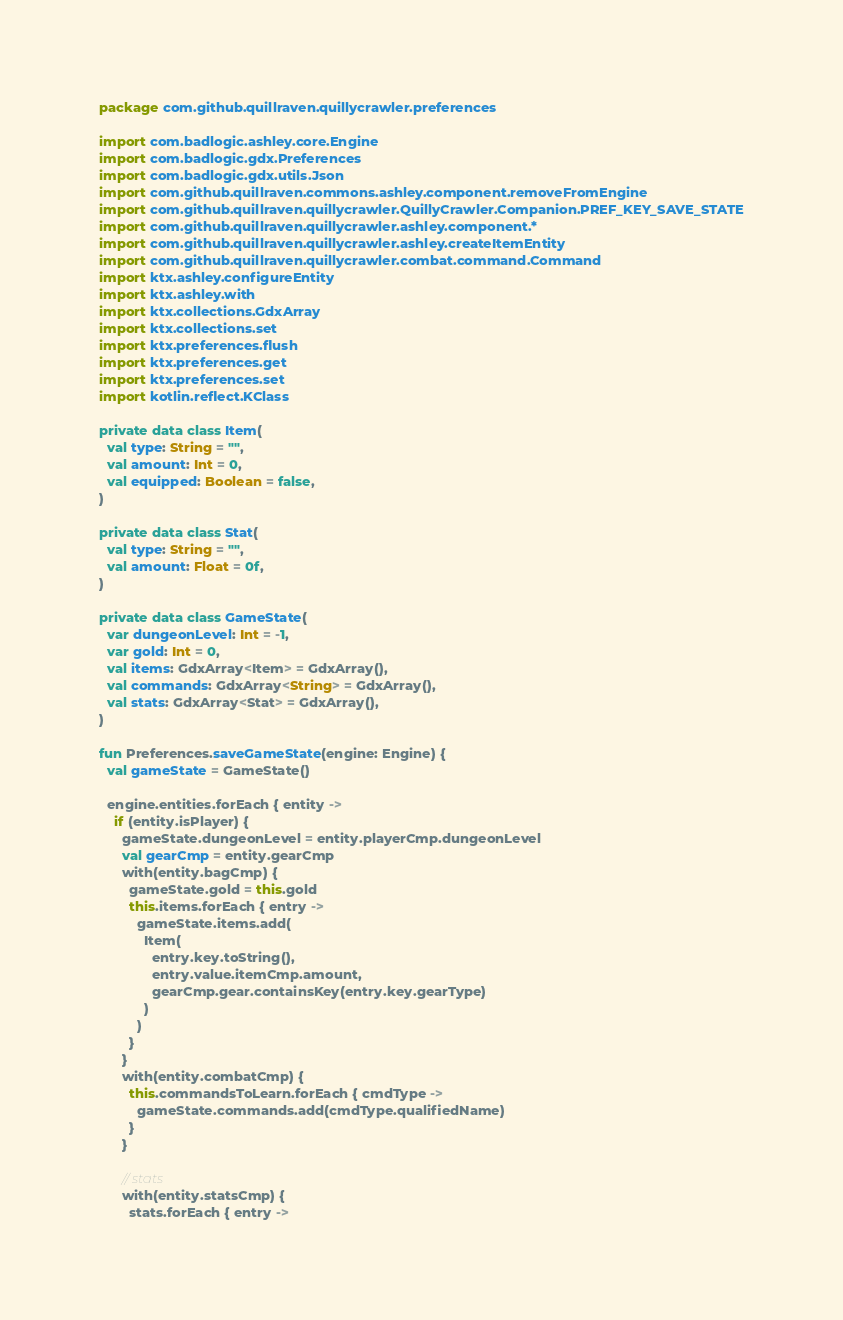<code> <loc_0><loc_0><loc_500><loc_500><_Kotlin_>package com.github.quillraven.quillycrawler.preferences

import com.badlogic.ashley.core.Engine
import com.badlogic.gdx.Preferences
import com.badlogic.gdx.utils.Json
import com.github.quillraven.commons.ashley.component.removeFromEngine
import com.github.quillraven.quillycrawler.QuillyCrawler.Companion.PREF_KEY_SAVE_STATE
import com.github.quillraven.quillycrawler.ashley.component.*
import com.github.quillraven.quillycrawler.ashley.createItemEntity
import com.github.quillraven.quillycrawler.combat.command.Command
import ktx.ashley.configureEntity
import ktx.ashley.with
import ktx.collections.GdxArray
import ktx.collections.set
import ktx.preferences.flush
import ktx.preferences.get
import ktx.preferences.set
import kotlin.reflect.KClass

private data class Item(
  val type: String = "",
  val amount: Int = 0,
  val equipped: Boolean = false,
)

private data class Stat(
  val type: String = "",
  val amount: Float = 0f,
)

private data class GameState(
  var dungeonLevel: Int = -1,
  var gold: Int = 0,
  val items: GdxArray<Item> = GdxArray(),
  val commands: GdxArray<String> = GdxArray(),
  val stats: GdxArray<Stat> = GdxArray(),
)

fun Preferences.saveGameState(engine: Engine) {
  val gameState = GameState()

  engine.entities.forEach { entity ->
    if (entity.isPlayer) {
      gameState.dungeonLevel = entity.playerCmp.dungeonLevel
      val gearCmp = entity.gearCmp
      with(entity.bagCmp) {
        gameState.gold = this.gold
        this.items.forEach { entry ->
          gameState.items.add(
            Item(
              entry.key.toString(),
              entry.value.itemCmp.amount,
              gearCmp.gear.containsKey(entry.key.gearType)
            )
          )
        }
      }
      with(entity.combatCmp) {
        this.commandsToLearn.forEach { cmdType ->
          gameState.commands.add(cmdType.qualifiedName)
        }
      }

      // stats
      with(entity.statsCmp) {
        stats.forEach { entry -></code> 